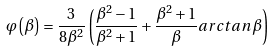<formula> <loc_0><loc_0><loc_500><loc_500>\varphi \left ( \beta \right ) = \frac { 3 } { 8 \beta ^ { 2 } } \left ( \frac { \beta ^ { 2 } - 1 } { \beta ^ { 2 } + 1 } + \frac { \beta ^ { 2 } + 1 } { \beta } a r c t a n \, \beta \right )</formula> 